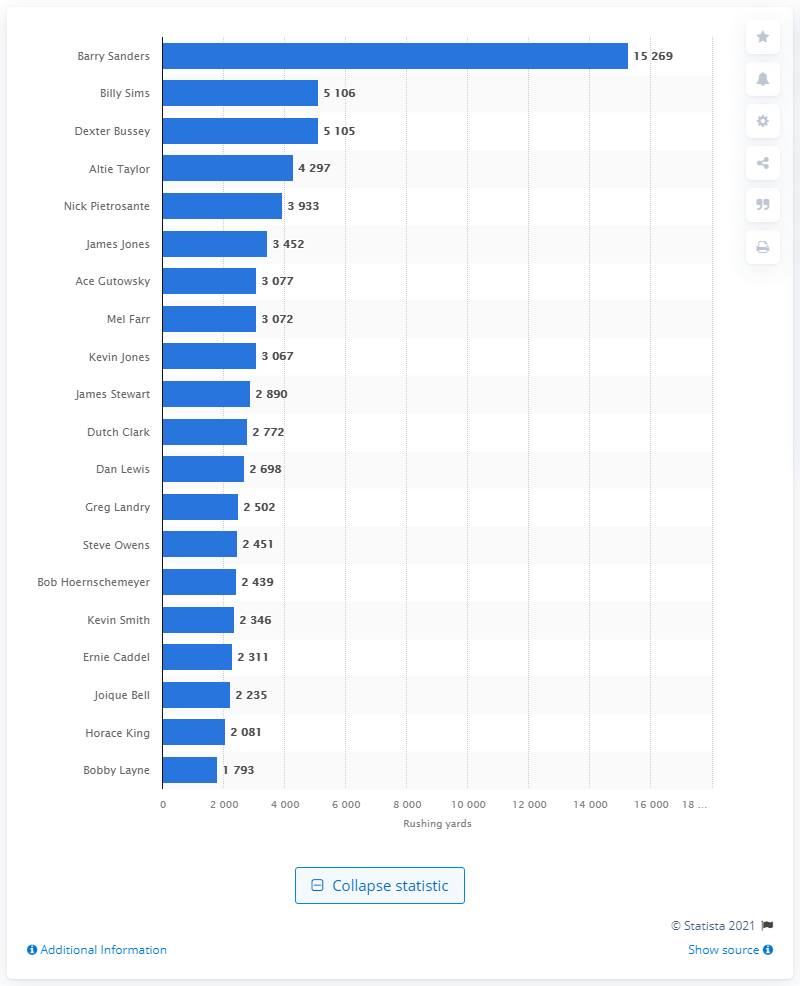Draw attention to some important aspects in this diagram. The career rushing leader of the Detroit Lions is Barry Sanders. 